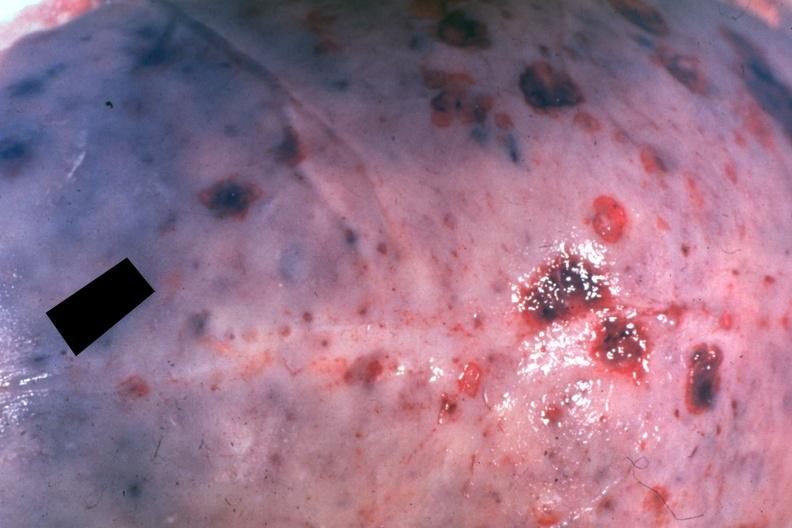s bone, calvarium present?
Answer the question using a single word or phrase. Yes 